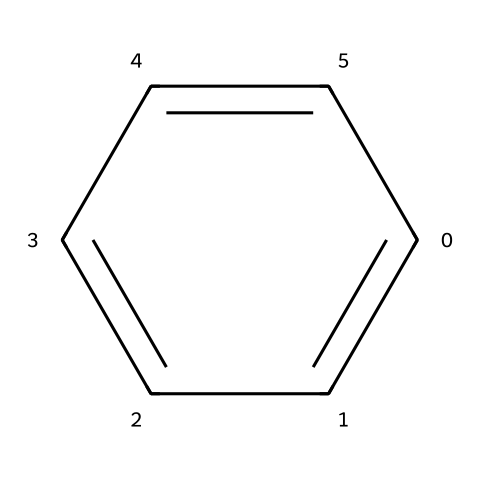How many carbon atoms are in benzene? The SMILES representation shows a six-membered carbon ring with alternating double bonds. Each "c" in the SMILES indicates a carbon atom. Counting them gives a total of six carbon atoms.
Answer: six What is the hybridization of the carbon atoms in benzene? The structure of benzene has sp2 hybridized carbon atoms due to the presence of one double bond with each adjacent carbon atom, leading to a trigonal planar geometry around each carbon.
Answer: sp2 How many resonance forms can benzene have? Benzene has multiple resonance forms that represent the delocalization of electrons in the ring. However, by traditional resonance, it is considered to have two primary resonance forms which depict the alternating double bonds shifting.
Answer: two What type of aromatic compound is benzene classified as? Benzene is classified as a monoaromatic compound because it contains a single aromatic ring structure without additional substituents or rings.
Answer: monoaromatic What is the bond order of the carbon-carbon bonds in benzene? In benzene, the bonds between the carbon atoms are not purely single or double due to resonance; each carbon-carbon bond is effectively a blend of one single bond and one double bond, leading to a bond order of 1.5 for each bond.
Answer: 1.5 Why is benzene considered stable despite having double bonds? Benzene's stability stems from resonance, where the electrons are delocalized across the ring rather than localized between individual carbon pairs. This delocalization lowers the overall energy of the molecule, making it more stable than expected for a structure with double bonds.
Answer: resonance stability 